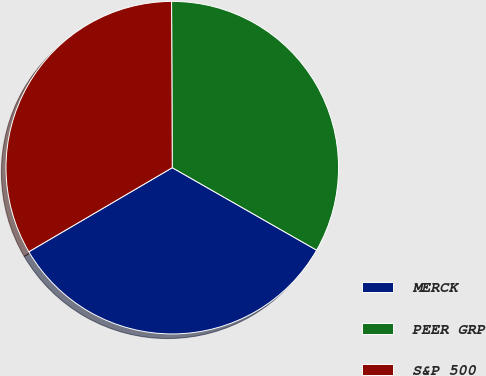<chart> <loc_0><loc_0><loc_500><loc_500><pie_chart><fcel>MERCK<fcel>PEER GRP<fcel>S&P 500<nl><fcel>33.3%<fcel>33.33%<fcel>33.37%<nl></chart> 